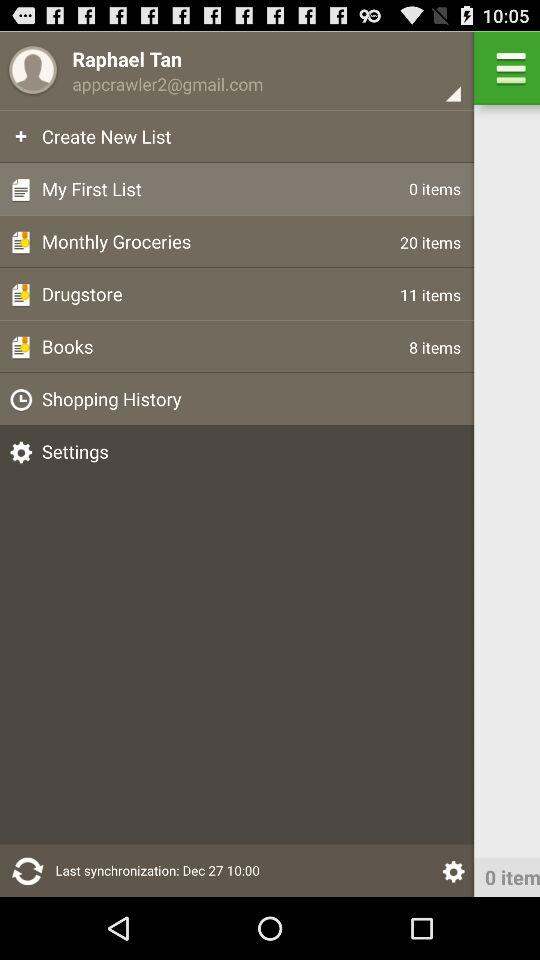What is the user name? The user name is Raphael Tan. 